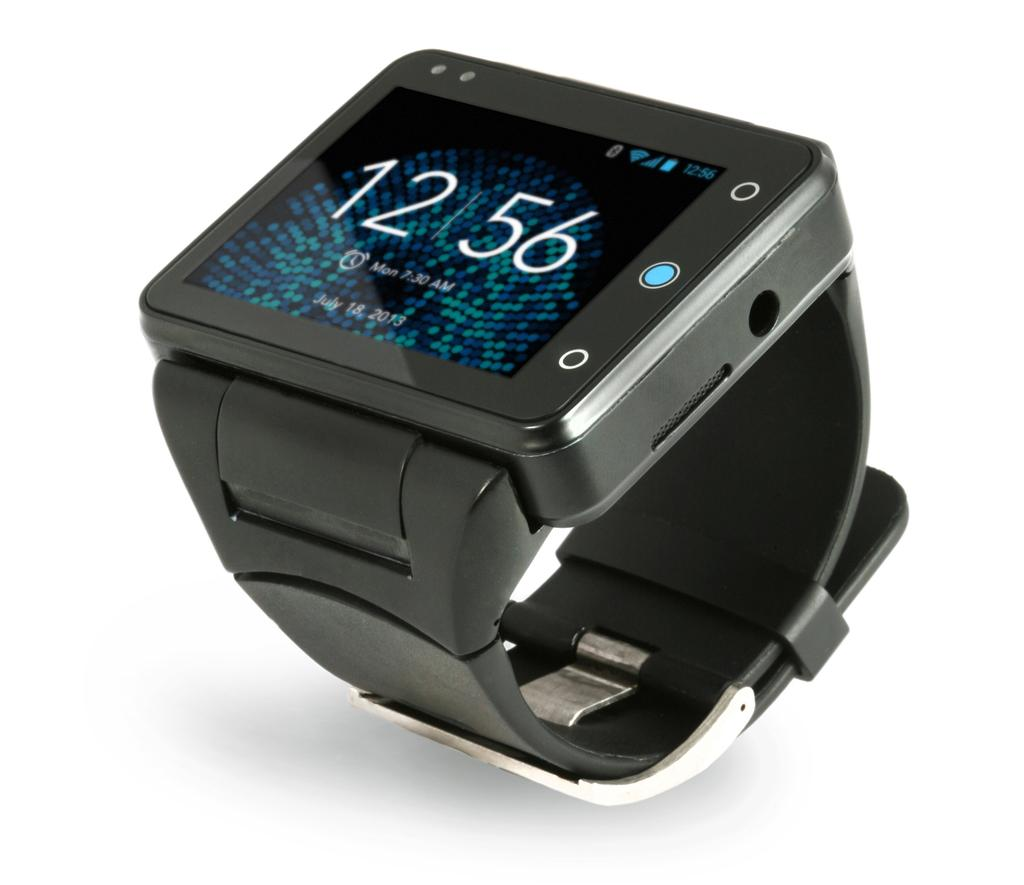<image>
Summarize the visual content of the image. A black smart watch with its screen on showing the time as well as Mon. 